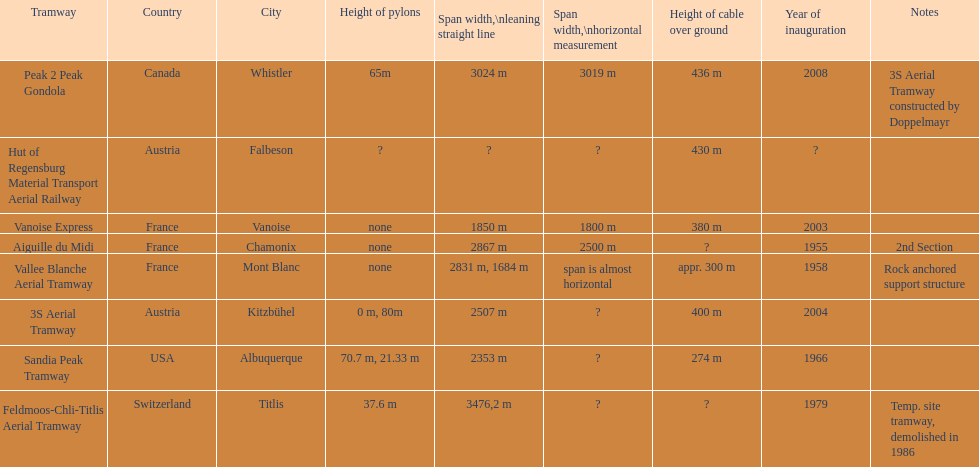Was the sandia peak tramway commencement before or after the 3s aerial tramway? Before. 